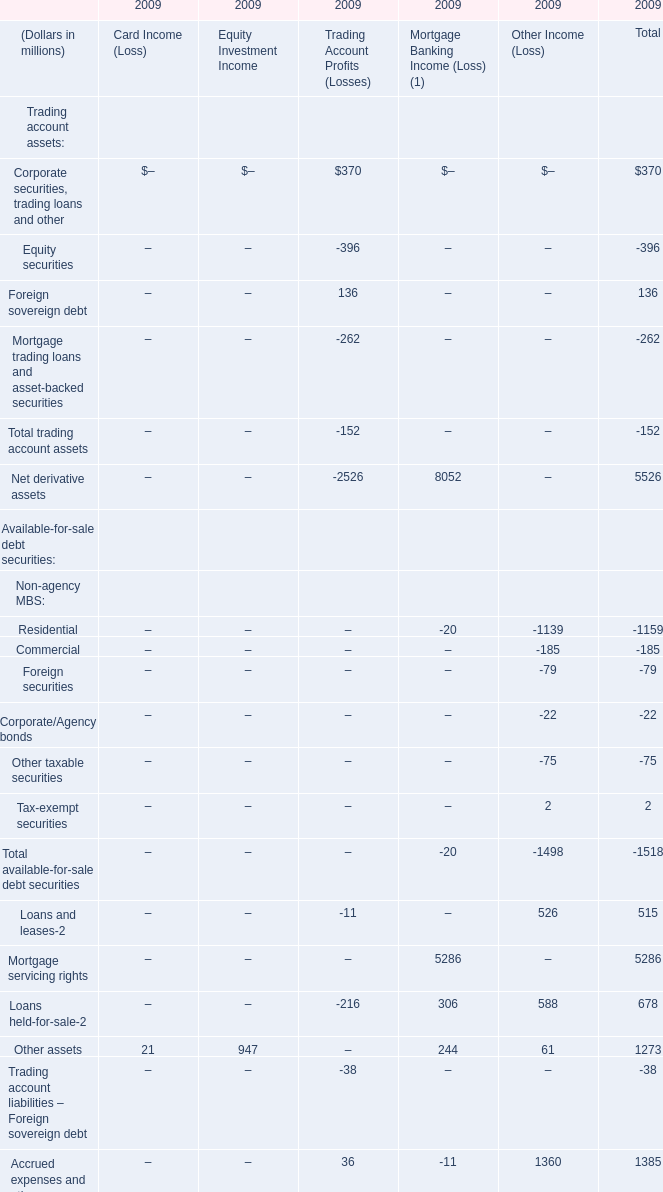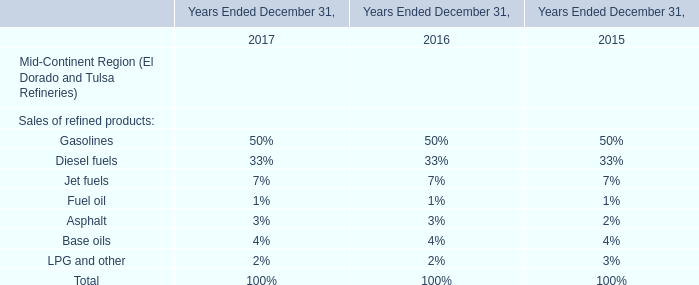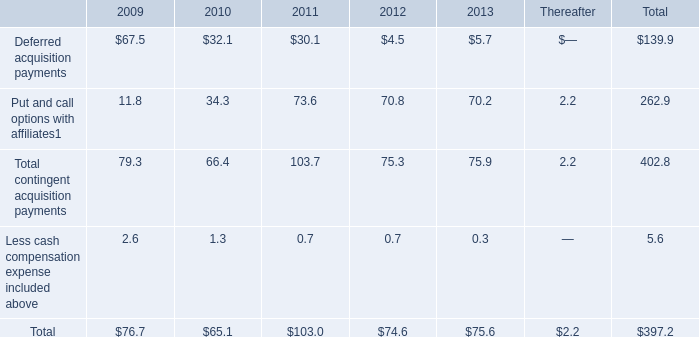what is the percentage change in the amount of guarantees from parent company from 2007 to 2008? 
Computations: ((255.7 - 327.1) / 327.1)
Answer: -0.21828. 